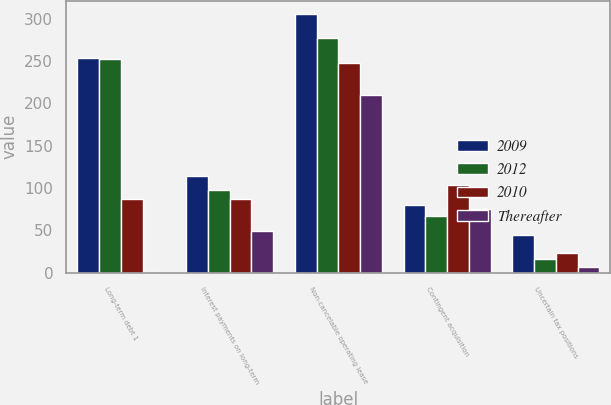<chart> <loc_0><loc_0><loc_500><loc_500><stacked_bar_chart><ecel><fcel>Long-term debt 1<fcel>Interest payments on long-term<fcel>Non-cancelable operating lease<fcel>Contingent acquisition<fcel>Uncertain tax positions<nl><fcel>2009<fcel>254.1<fcel>113.9<fcel>305.7<fcel>79.3<fcel>44.3<nl><fcel>2012<fcel>252.2<fcel>97.5<fcel>277.6<fcel>66.4<fcel>15.7<nl><fcel>2010<fcel>86.7<fcel>86.7<fcel>247.6<fcel>103.7<fcel>23.5<nl><fcel>Thereafter<fcel>0.8<fcel>48.8<fcel>209.4<fcel>75.3<fcel>6.5<nl></chart> 